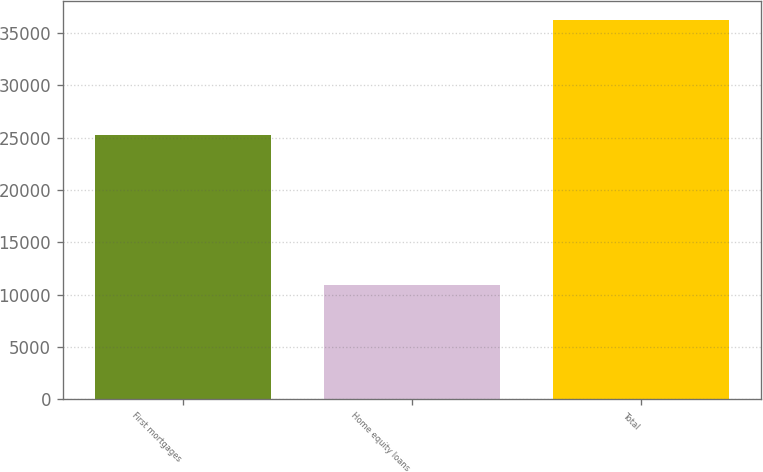<chart> <loc_0><loc_0><loc_500><loc_500><bar_chart><fcel>First mortgages<fcel>Home equity loans<fcel>Total<nl><fcel>25311<fcel>10940<fcel>36251<nl></chart> 